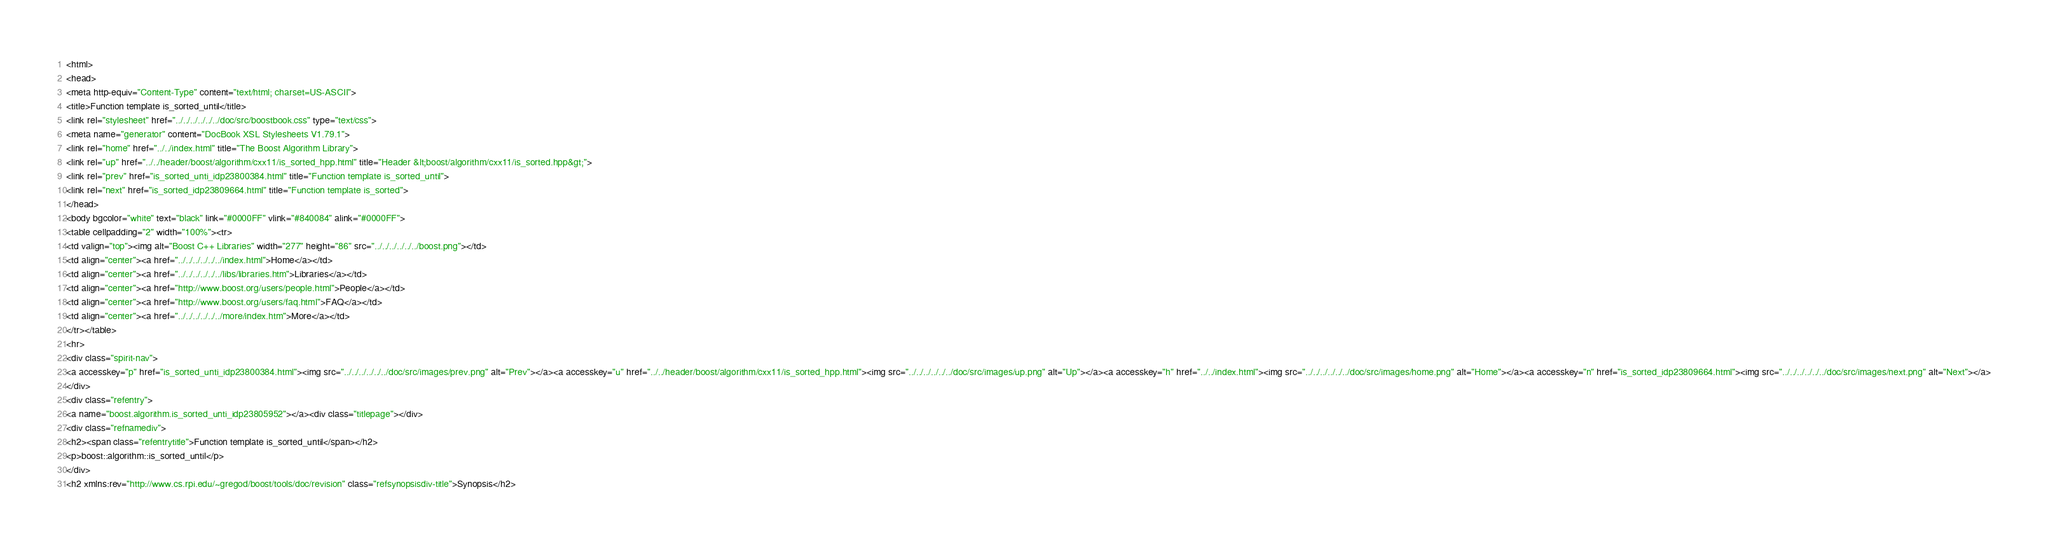Convert code to text. <code><loc_0><loc_0><loc_500><loc_500><_HTML_><html>
<head>
<meta http-equiv="Content-Type" content="text/html; charset=US-ASCII">
<title>Function template is_sorted_until</title>
<link rel="stylesheet" href="../../../../../../doc/src/boostbook.css" type="text/css">
<meta name="generator" content="DocBook XSL Stylesheets V1.79.1">
<link rel="home" href="../../index.html" title="The Boost Algorithm Library">
<link rel="up" href="../../header/boost/algorithm/cxx11/is_sorted_hpp.html" title="Header &lt;boost/algorithm/cxx11/is_sorted.hpp&gt;">
<link rel="prev" href="is_sorted_unti_idp23800384.html" title="Function template is_sorted_until">
<link rel="next" href="is_sorted_idp23809664.html" title="Function template is_sorted">
</head>
<body bgcolor="white" text="black" link="#0000FF" vlink="#840084" alink="#0000FF">
<table cellpadding="2" width="100%"><tr>
<td valign="top"><img alt="Boost C++ Libraries" width="277" height="86" src="../../../../../../boost.png"></td>
<td align="center"><a href="../../../../../../index.html">Home</a></td>
<td align="center"><a href="../../../../../../libs/libraries.htm">Libraries</a></td>
<td align="center"><a href="http://www.boost.org/users/people.html">People</a></td>
<td align="center"><a href="http://www.boost.org/users/faq.html">FAQ</a></td>
<td align="center"><a href="../../../../../../more/index.htm">More</a></td>
</tr></table>
<hr>
<div class="spirit-nav">
<a accesskey="p" href="is_sorted_unti_idp23800384.html"><img src="../../../../../../doc/src/images/prev.png" alt="Prev"></a><a accesskey="u" href="../../header/boost/algorithm/cxx11/is_sorted_hpp.html"><img src="../../../../../../doc/src/images/up.png" alt="Up"></a><a accesskey="h" href="../../index.html"><img src="../../../../../../doc/src/images/home.png" alt="Home"></a><a accesskey="n" href="is_sorted_idp23809664.html"><img src="../../../../../../doc/src/images/next.png" alt="Next"></a>
</div>
<div class="refentry">
<a name="boost.algorithm.is_sorted_unti_idp23805952"></a><div class="titlepage"></div>
<div class="refnamediv">
<h2><span class="refentrytitle">Function template is_sorted_until</span></h2>
<p>boost::algorithm::is_sorted_until</p>
</div>
<h2 xmlns:rev="http://www.cs.rpi.edu/~gregod/boost/tools/doc/revision" class="refsynopsisdiv-title">Synopsis</h2></code> 